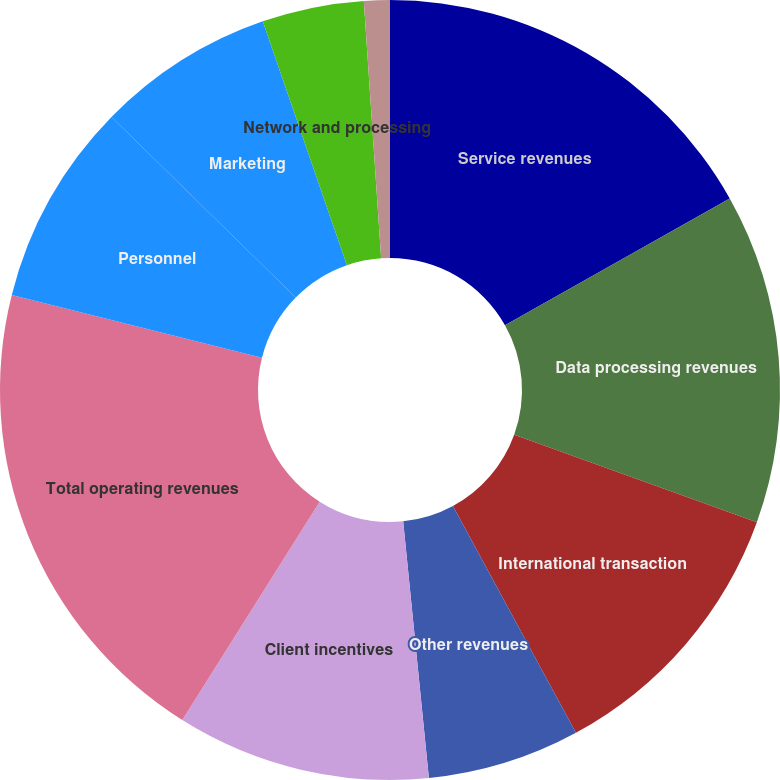Convert chart to OTSL. <chart><loc_0><loc_0><loc_500><loc_500><pie_chart><fcel>Service revenues<fcel>Data processing revenues<fcel>International transaction<fcel>Other revenues<fcel>Client incentives<fcel>Total operating revenues<fcel>Personnel<fcel>Marketing<fcel>Network and processing<fcel>Professional fees<nl><fcel>16.83%<fcel>13.68%<fcel>11.58%<fcel>6.32%<fcel>10.53%<fcel>19.98%<fcel>8.42%<fcel>7.37%<fcel>4.22%<fcel>1.07%<nl></chart> 